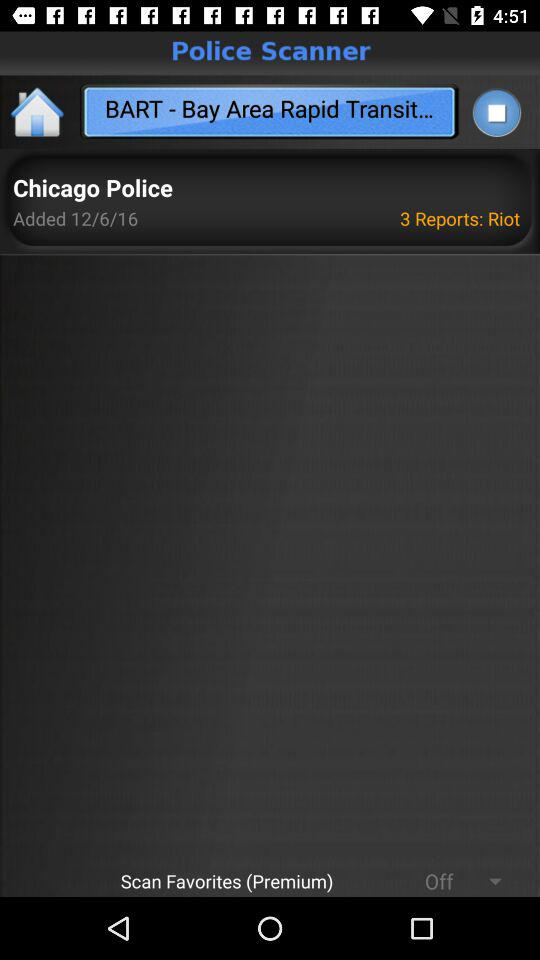When were the reports added? The reports were added on 12/6/16. 